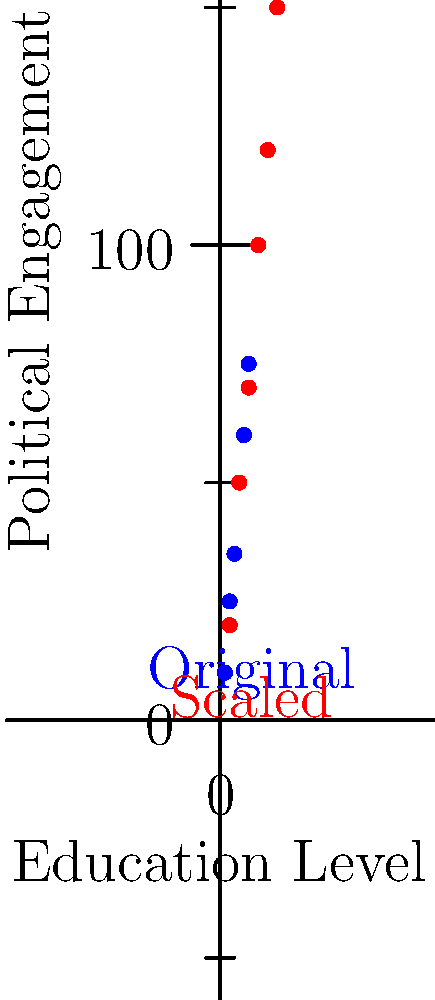A scatter plot showing the correlation between education level and political engagement in Denmark has been scaled. If the original coordinates of a point were $(3, 35)$, what are its new coordinates after scaling? To solve this problem, we need to determine the scaling factor used for both the x and y coordinates:

1. Observe the original and scaled points:
   - Original: $(1, 10)$, $(2, 25)$, $(3, 35)$, $(4, 50)$, $(5, 60)$, $(6, 75)$
   - Scaled: $(2, 20)$, $(4, 50)$, $(6, 70)$, $(8, 100)$, $(10, 120)$, $(12, 150)$

2. Calculate the scaling factor for x-coordinates:
   $\frac{2}{1} = \frac{4}{2} = \frac{6}{3} = 2$
   The x-coordinates are multiplied by 2.

3. Calculate the scaling factor for y-coordinates:
   $\frac{20}{10} = \frac{50}{25} = \frac{70}{35} = 2$
   The y-coordinates are also multiplied by 2.

4. Apply the scaling factors to the given point $(3, 35)$:
   - New x-coordinate: $3 \times 2 = 6$
   - New y-coordinate: $35 \times 2 = 70$

5. The new coordinates after scaling are $(6, 70)$.
Answer: $(6, 70)$ 